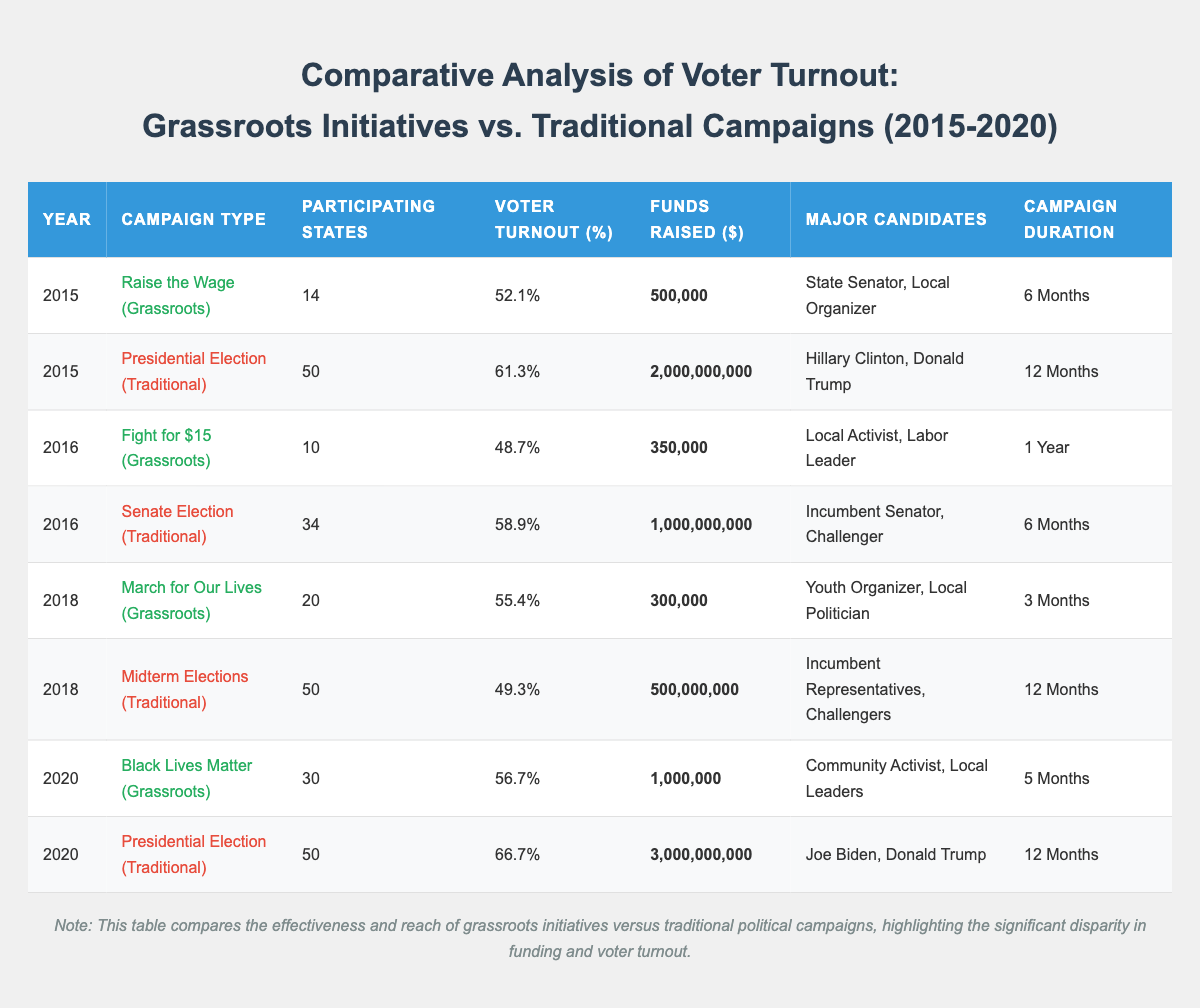What was the voter turnout percentage for the grassroots initiative "Fight for $15"? In the 2016 row for the grassroots initiatives, the voter turnout percentage listed for "Fight for $15" is 48.7%.
Answer: 48.7% Which campaign raised the most funds in 2020? Among the 2020 entries, the traditional campaign "Presidential Election" raised the most funds, totaling $3,000,000,000.
Answer: $3,000,000,000 How many participating states were involved in the "March for Our Lives" campaign? The table shows that "March for Our Lives" in 2018 had 20 participating states listed.
Answer: 20 What is the difference in voter turnout between the 2015 Presidential Election and the Grassroots Initiative "Raise the Wage"? The 2015 Presidential Election had a voter turnout of 61.3%, while "Raise the Wage" had 52.1%. The difference is calculated as 61.3% - 52.1% = 9.2%.
Answer: 9.2% What was the average voter turnout percentage for grassroots initiatives from 2015 to 2020? The voter turnout percentages for grassroots initiatives are as follows: 52.1% (2015), 48.7% (2016), 55.4% (2018), and 56.7% (2020). The average is calculated as (52.1 + 48.7 + 55.4 + 56.7) / 4 = 53.2%.
Answer: 53.2% Was the voter turnout in the 2020 "Black Lives Matter" initiative higher or lower than in the 2018 "Midterm Elections"? The voter turnout for "Black Lives Matter" in 2020 was 56.7%, while the "Midterm Elections" in 2018 had a turnout of 49.3%. Since 56.7% is greater than 49.3%, the turnout for "Black Lives Matter" was higher.
Answer: Higher Which campaign had the longest duration among the grassroots initiatives? The grassroots initiatives table shows that "Fight for $15" in 2016 lasted for 1 year, while the other grassroots initiatives lasted for shorter durations (6 months, 3 months, and 5 months). Thus, "Fight for $15" had the longest duration.
Answer: Fight for $15 What was the total funds raised by all grassroots initiatives from 2015 to 2020? The funds raised are: $500,000 (2015), $350,000 (2016), $300,000 (2018), and $1,000,000 (2020). Summing these gives $500,000 + $350,000 + $300,000 + $1,000,000 = $2,150,000.
Answer: $2,150,000 How many campaigns in total participated in the grassroots initiatives compared to traditional campaigns? For grassroots initiatives: 4 campaigns (one for each year from 2015 to 2020). For traditional campaigns: 4 campaigns, also one for each year (with two Presidential Elections). Thus, there were 4 grassroots and 4 traditional campaigns, meaning they are equal.
Answer: Equal Which year had the highest voter turnout for grassroots initiatives? The highest voter turnout percentage for grassroots initiatives was 56.7% in 2020 for "Black Lives Matter."
Answer: 2020 